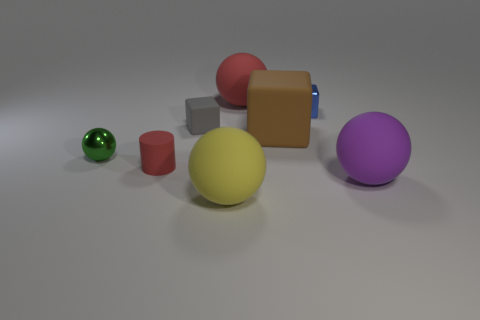Subtract all yellow spheres. How many spheres are left? 3 Subtract all green balls. How many balls are left? 3 Add 1 big yellow rubber blocks. How many objects exist? 9 Subtract all cylinders. How many objects are left? 7 Subtract 3 cubes. How many cubes are left? 0 Add 3 red metal things. How many red metal things exist? 3 Subtract 1 red spheres. How many objects are left? 7 Subtract all cyan cylinders. Subtract all blue cubes. How many cylinders are left? 1 Subtract all blue metallic objects. Subtract all small rubber cubes. How many objects are left? 6 Add 5 matte balls. How many matte balls are left? 8 